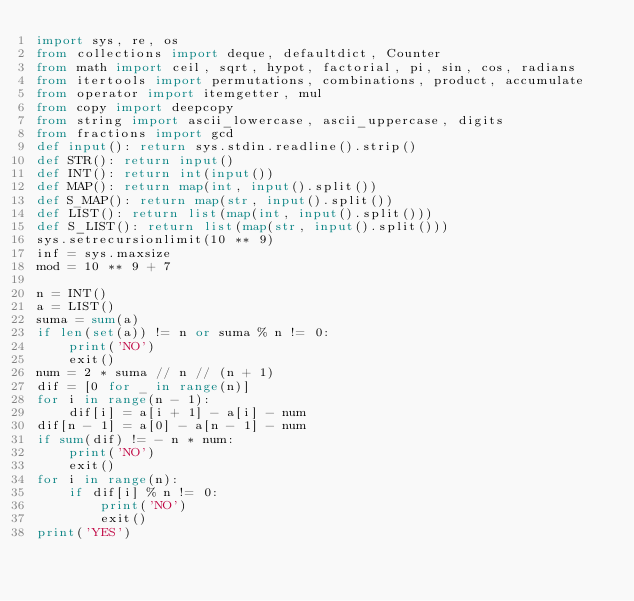<code> <loc_0><loc_0><loc_500><loc_500><_Python_>import sys, re, os
from collections import deque, defaultdict, Counter
from math import ceil, sqrt, hypot, factorial, pi, sin, cos, radians
from itertools import permutations, combinations, product, accumulate
from operator import itemgetter, mul
from copy import deepcopy
from string import ascii_lowercase, ascii_uppercase, digits
from fractions import gcd
def input(): return sys.stdin.readline().strip()
def STR(): return input()
def INT(): return int(input())
def MAP(): return map(int, input().split())
def S_MAP(): return map(str, input().split())
def LIST(): return list(map(int, input().split()))
def S_LIST(): return list(map(str, input().split()))
sys.setrecursionlimit(10 ** 9)
inf = sys.maxsize
mod = 10 ** 9 + 7

n = INT()
a = LIST()
suma = sum(a)
if len(set(a)) != n or suma % n != 0:
    print('NO')
    exit()
num = 2 * suma // n // (n + 1)
dif = [0 for _ in range(n)]
for i in range(n - 1):
    dif[i] = a[i + 1] - a[i] - num
dif[n - 1] = a[0] - a[n - 1] - num
if sum(dif) != - n * num:
    print('NO')
    exit()
for i in range(n):
    if dif[i] % n != 0:
        print('NO')
        exit()
print('YES')</code> 